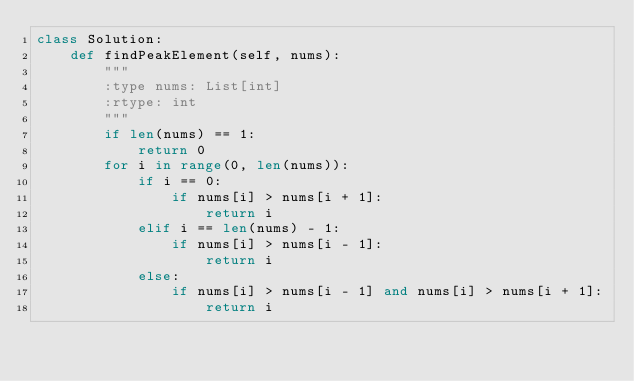<code> <loc_0><loc_0><loc_500><loc_500><_Python_>class Solution:
    def findPeakElement(self, nums):
        """
        :type nums: List[int]
        :rtype: int
        """
        if len(nums) == 1:
            return 0
        for i in range(0, len(nums)):
            if i == 0:
                if nums[i] > nums[i + 1]:
                    return i
            elif i == len(nums) - 1:
                if nums[i] > nums[i - 1]:
                    return i
            else:
                if nums[i] > nums[i - 1] and nums[i] > nums[i + 1]:
                    return i
</code> 